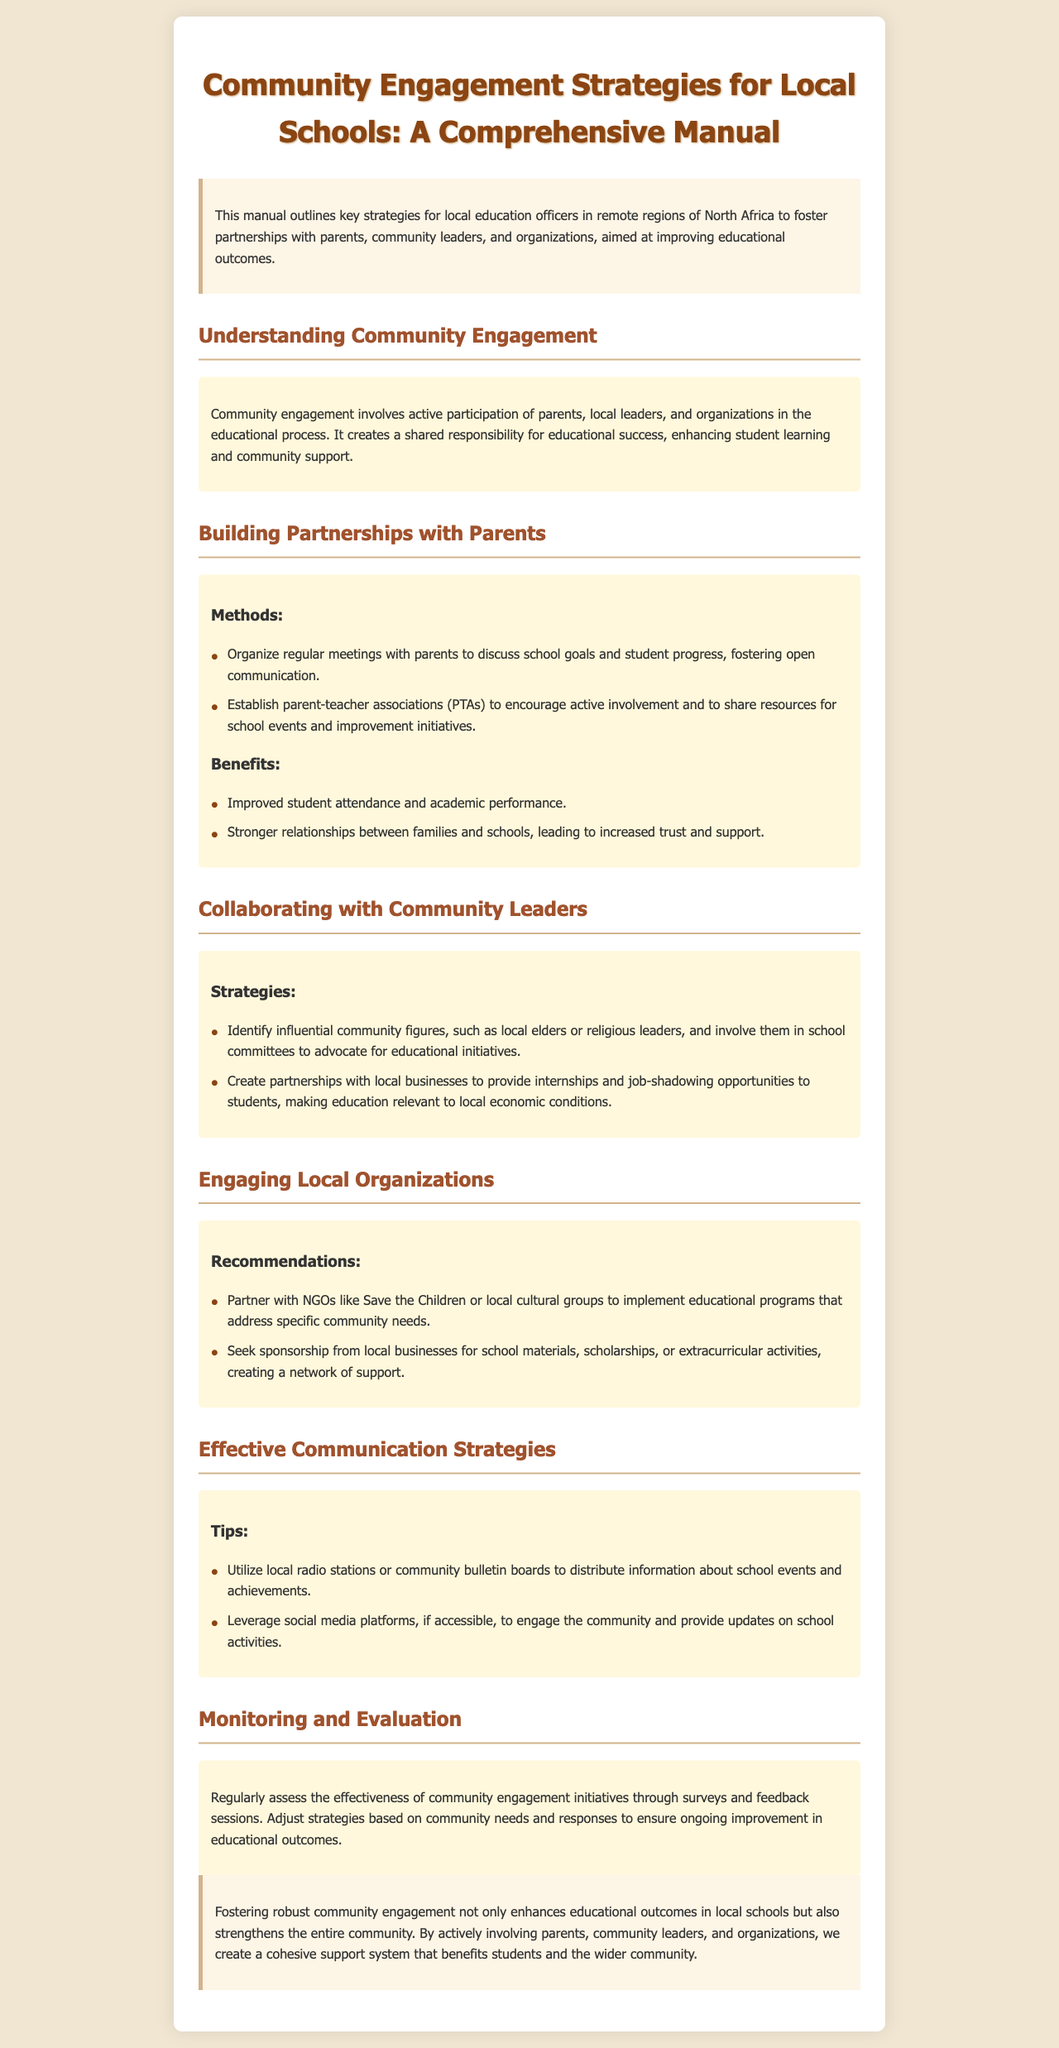What is the title of the manual? The title is found in the header of the document, specifying the subject of the manual.
Answer: Community Engagement Strategies for Local Schools: A Comprehensive Manual Who should be involved in community engagement according to the document? The document outlines key stakeholders for community engagement in education.
Answer: Parents, community leaders, and organizations What are the benefits of building partnerships with parents? The document lists advantages of parent involvement in schools, reflecting on student outcomes.
Answer: Improved student attendance and academic performance What strategies are recommended for collaborating with community leaders? The document discusses strategies for effective collaboration with influential figures in the community.
Answer: Identify influential community figures and create partnerships with local businesses Which organizations does the manual suggest partnering with? The document mentions organizations that can support educational initiatives within the community.
Answer: NGOs like Save the Children How can local schools communicate effectively with the community? The document offers communication strategies that enhance engagement and information sharing.
Answer: Utilize local radio stations or community bulletin boards What is the focus of the Monitoring and Evaluation section? The document identifies the purposes of assessing community engagement initiatives.
Answer: Regularly assess the effectiveness of community engagement initiatives What is one method listed for engaging parents? The document provides specific methods to involve parents in the educational process.
Answer: Organize regular meetings with parents What does the conclusion emphasize regarding community engagement? The conclusion summarizes the overall importance of community involvement in education.
Answer: Fostering robust community engagement enhances educational outcomes 